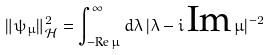Convert formula to latex. <formula><loc_0><loc_0><loc_500><loc_500>\| \psi _ { \mu } \| ^ { 2 } _ { \mathcal { H } } = \int _ { - \text {Re} \, \mu } ^ { \infty } d \lambda \, | \lambda - i \, \text {Im} \, \mu | ^ { - 2 }</formula> 